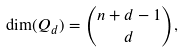<formula> <loc_0><loc_0><loc_500><loc_500>\dim ( Q _ { d } ) = { n + d - 1 \choose d } ,</formula> 